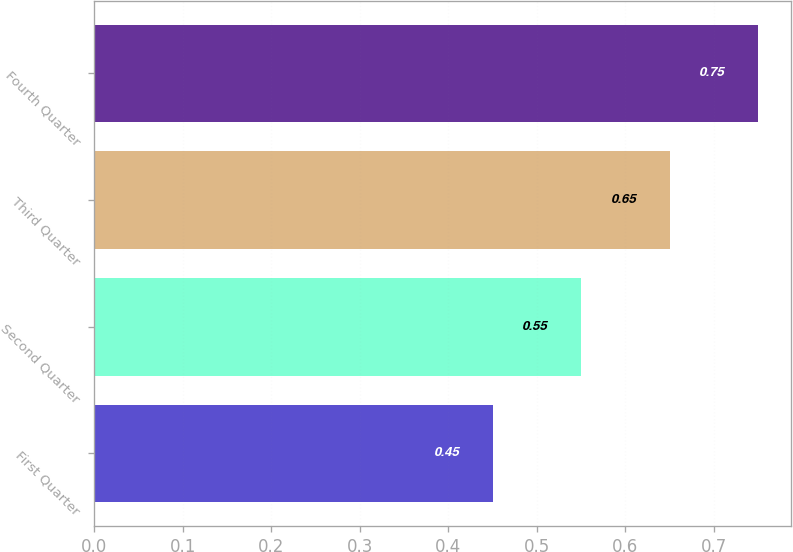<chart> <loc_0><loc_0><loc_500><loc_500><bar_chart><fcel>First Quarter<fcel>Second Quarter<fcel>Third Quarter<fcel>Fourth Quarter<nl><fcel>0.45<fcel>0.55<fcel>0.65<fcel>0.75<nl></chart> 